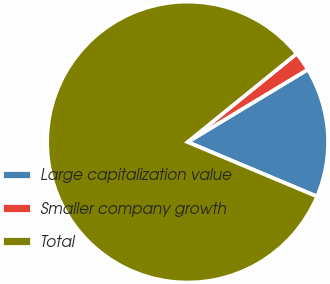Convert chart to OTSL. <chart><loc_0><loc_0><loc_500><loc_500><pie_chart><fcel>Large capitalization value<fcel>Smaller company growth<fcel>Total<nl><fcel>14.98%<fcel>2.2%<fcel>82.82%<nl></chart> 